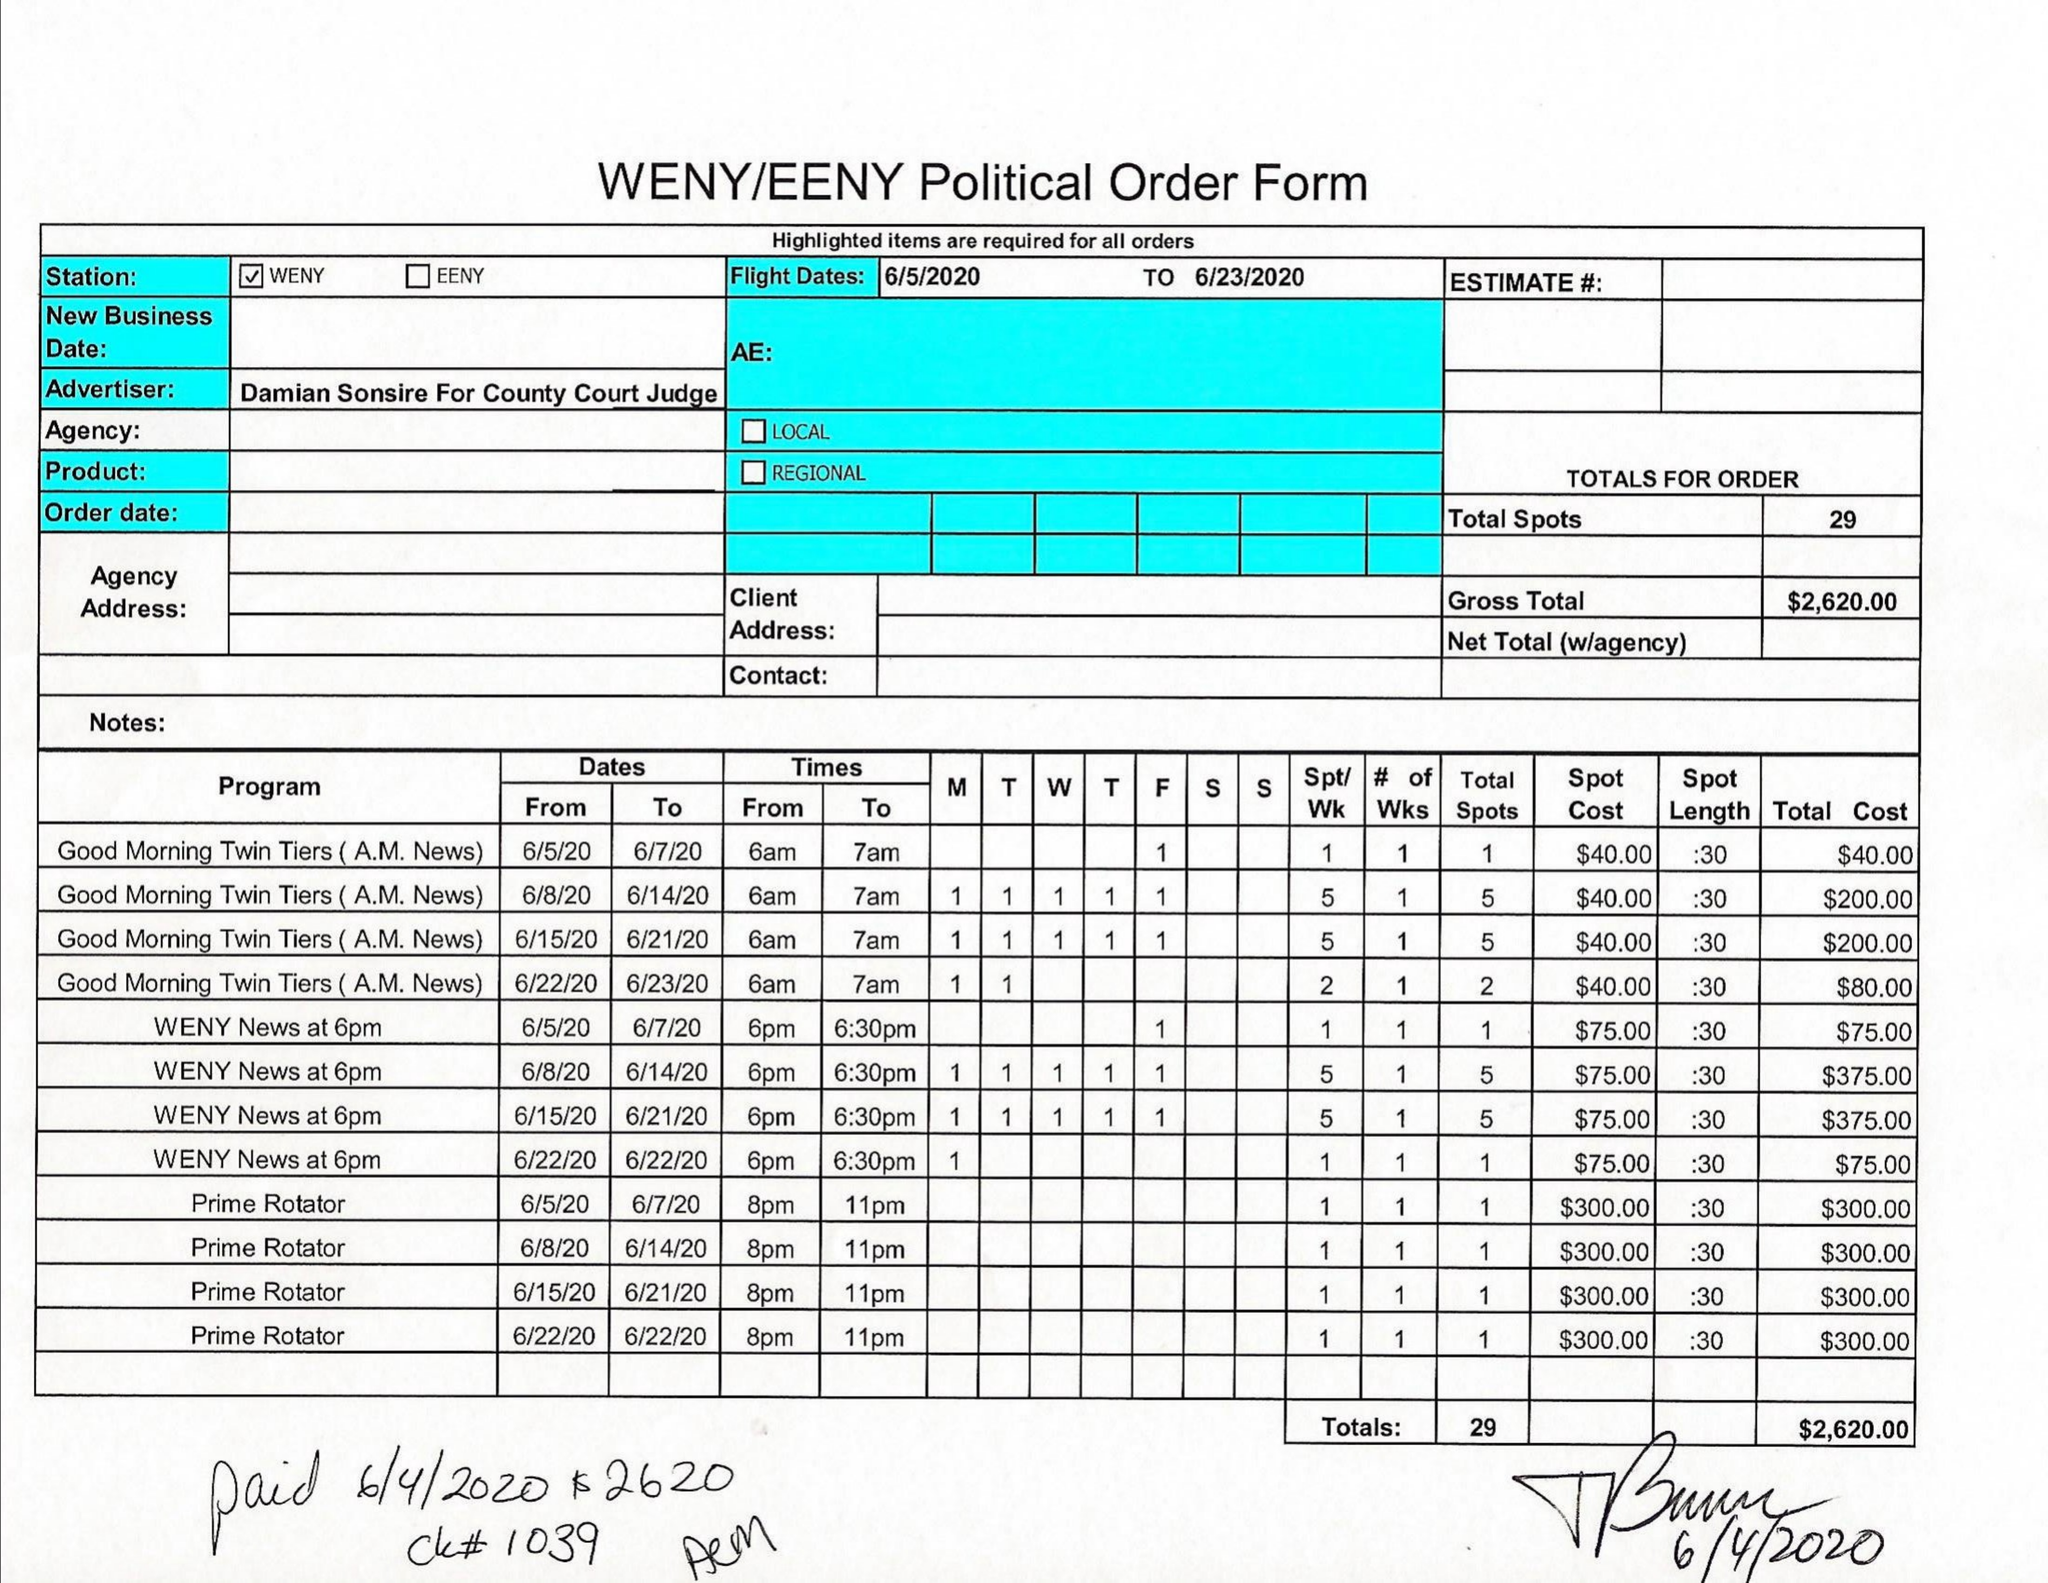What is the value for the gross_amount?
Answer the question using a single word or phrase. 2620.00 